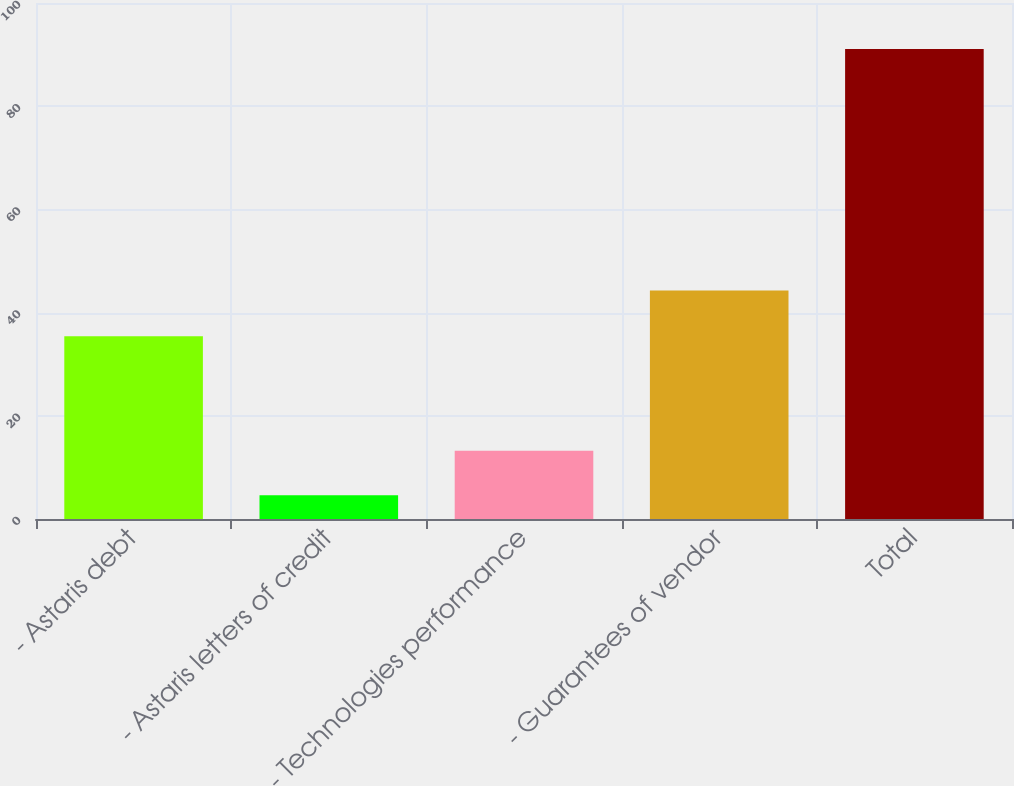Convert chart to OTSL. <chart><loc_0><loc_0><loc_500><loc_500><bar_chart><fcel>- Astaris debt<fcel>- Astaris letters of credit<fcel>- Technologies performance<fcel>- Guarantees of vendor<fcel>Total<nl><fcel>35.4<fcel>4.6<fcel>13.25<fcel>44.3<fcel>91.1<nl></chart> 